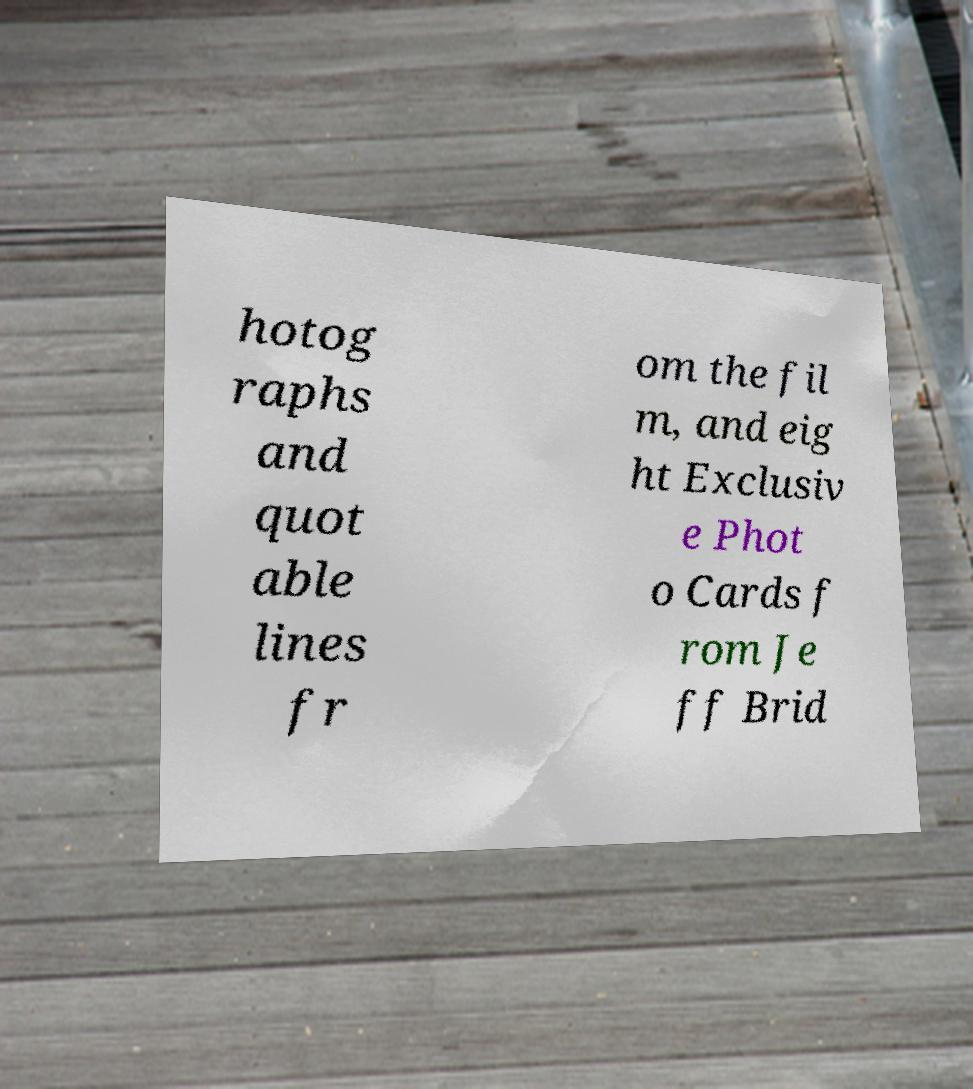There's text embedded in this image that I need extracted. Can you transcribe it verbatim? hotog raphs and quot able lines fr om the fil m, and eig ht Exclusiv e Phot o Cards f rom Je ff Brid 